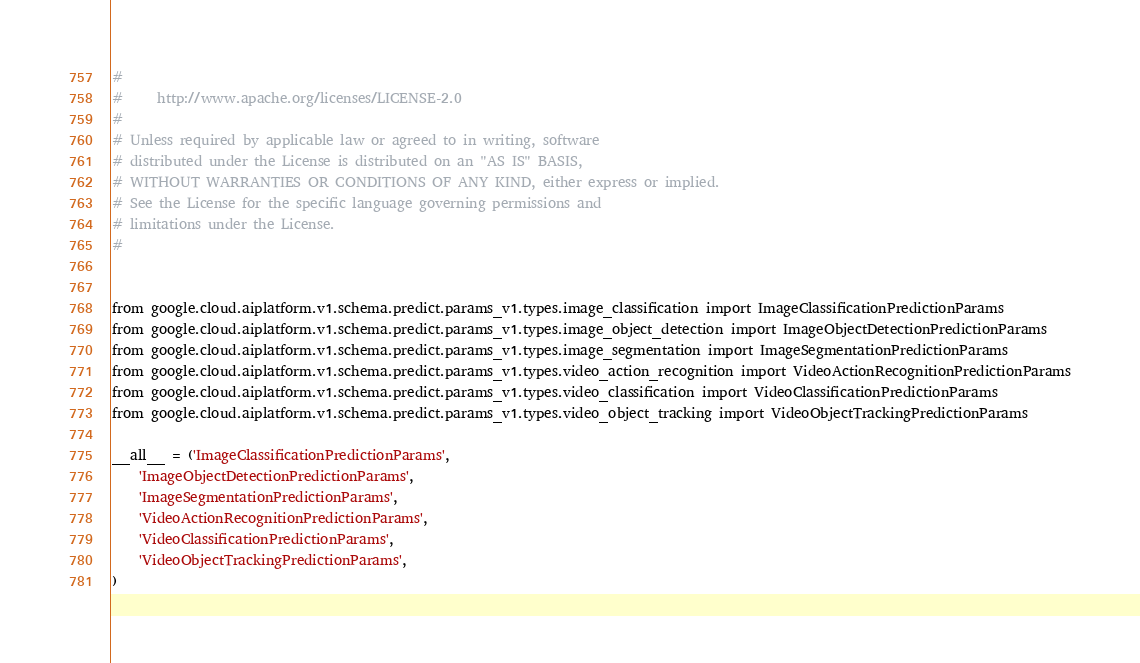<code> <loc_0><loc_0><loc_500><loc_500><_Python_>#
#     http://www.apache.org/licenses/LICENSE-2.0
#
# Unless required by applicable law or agreed to in writing, software
# distributed under the License is distributed on an "AS IS" BASIS,
# WITHOUT WARRANTIES OR CONDITIONS OF ANY KIND, either express or implied.
# See the License for the specific language governing permissions and
# limitations under the License.
#


from google.cloud.aiplatform.v1.schema.predict.params_v1.types.image_classification import ImageClassificationPredictionParams
from google.cloud.aiplatform.v1.schema.predict.params_v1.types.image_object_detection import ImageObjectDetectionPredictionParams
from google.cloud.aiplatform.v1.schema.predict.params_v1.types.image_segmentation import ImageSegmentationPredictionParams
from google.cloud.aiplatform.v1.schema.predict.params_v1.types.video_action_recognition import VideoActionRecognitionPredictionParams
from google.cloud.aiplatform.v1.schema.predict.params_v1.types.video_classification import VideoClassificationPredictionParams
from google.cloud.aiplatform.v1.schema.predict.params_v1.types.video_object_tracking import VideoObjectTrackingPredictionParams

__all__ = ('ImageClassificationPredictionParams',
    'ImageObjectDetectionPredictionParams',
    'ImageSegmentationPredictionParams',
    'VideoActionRecognitionPredictionParams',
    'VideoClassificationPredictionParams',
    'VideoObjectTrackingPredictionParams',
)
</code> 